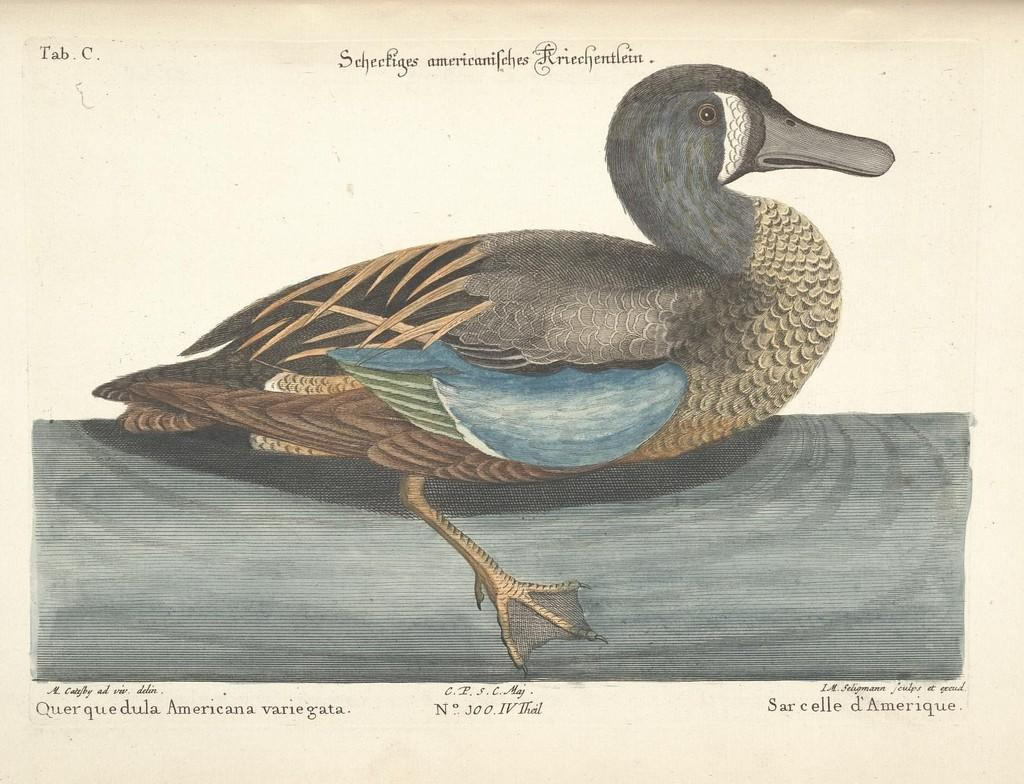What is the main subject of the image? There is a painting in the image. What is depicted in the painting? The painting contains a duck. Are there any words in the painting? Yes, there is text at the top and bottom of the painting. Can you tell me how many flowers are in the painting? There are no flowers present in the painting; it features a duck and text. Is the duck sleeping in the painting? The painting does not depict the duck's state of sleep; it only shows the duck and text. 